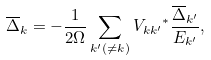Convert formula to latex. <formula><loc_0><loc_0><loc_500><loc_500>\overline { \Delta } _ { k } = - \frac { 1 } { 2 \Omega } \sum _ { { k } ^ { \prime } ( \neq { k } ) } { V _ { { k } { k } ^ { \prime } } } ^ { * } \frac { \overline { \Delta } _ { { k } ^ { \prime } } } { E _ { k ^ { \prime } } } ,</formula> 